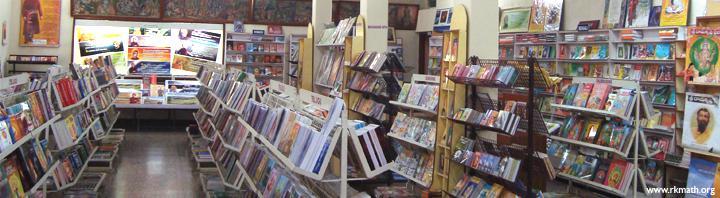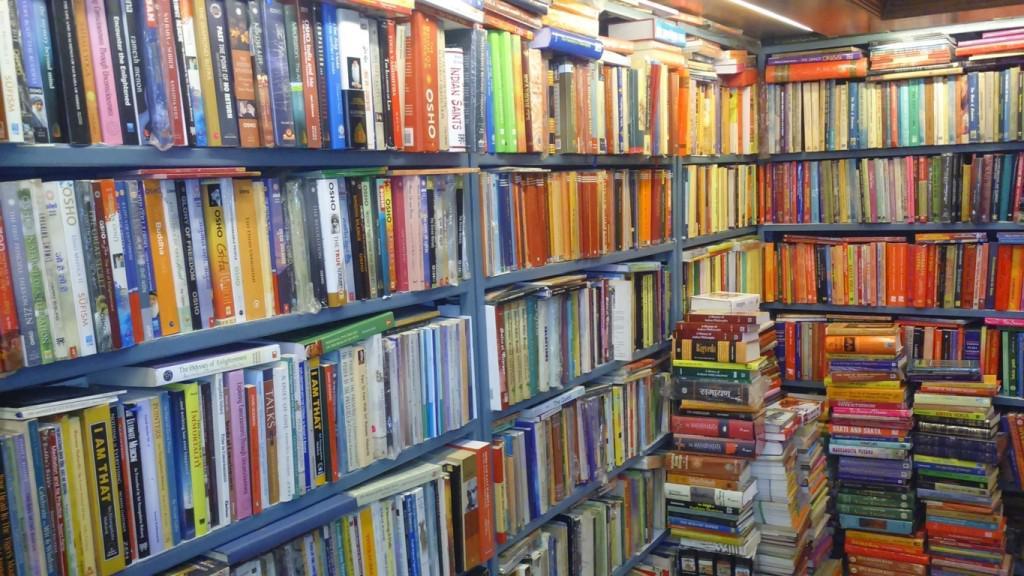The first image is the image on the left, the second image is the image on the right. Considering the images on both sides, is "At least 2 people are shopping for books in the bookstore." valid? Answer yes or no. No. The first image is the image on the left, the second image is the image on the right. Analyze the images presented: Is the assertion "People stand in the book store in the image on the right." valid? Answer yes or no. No. 